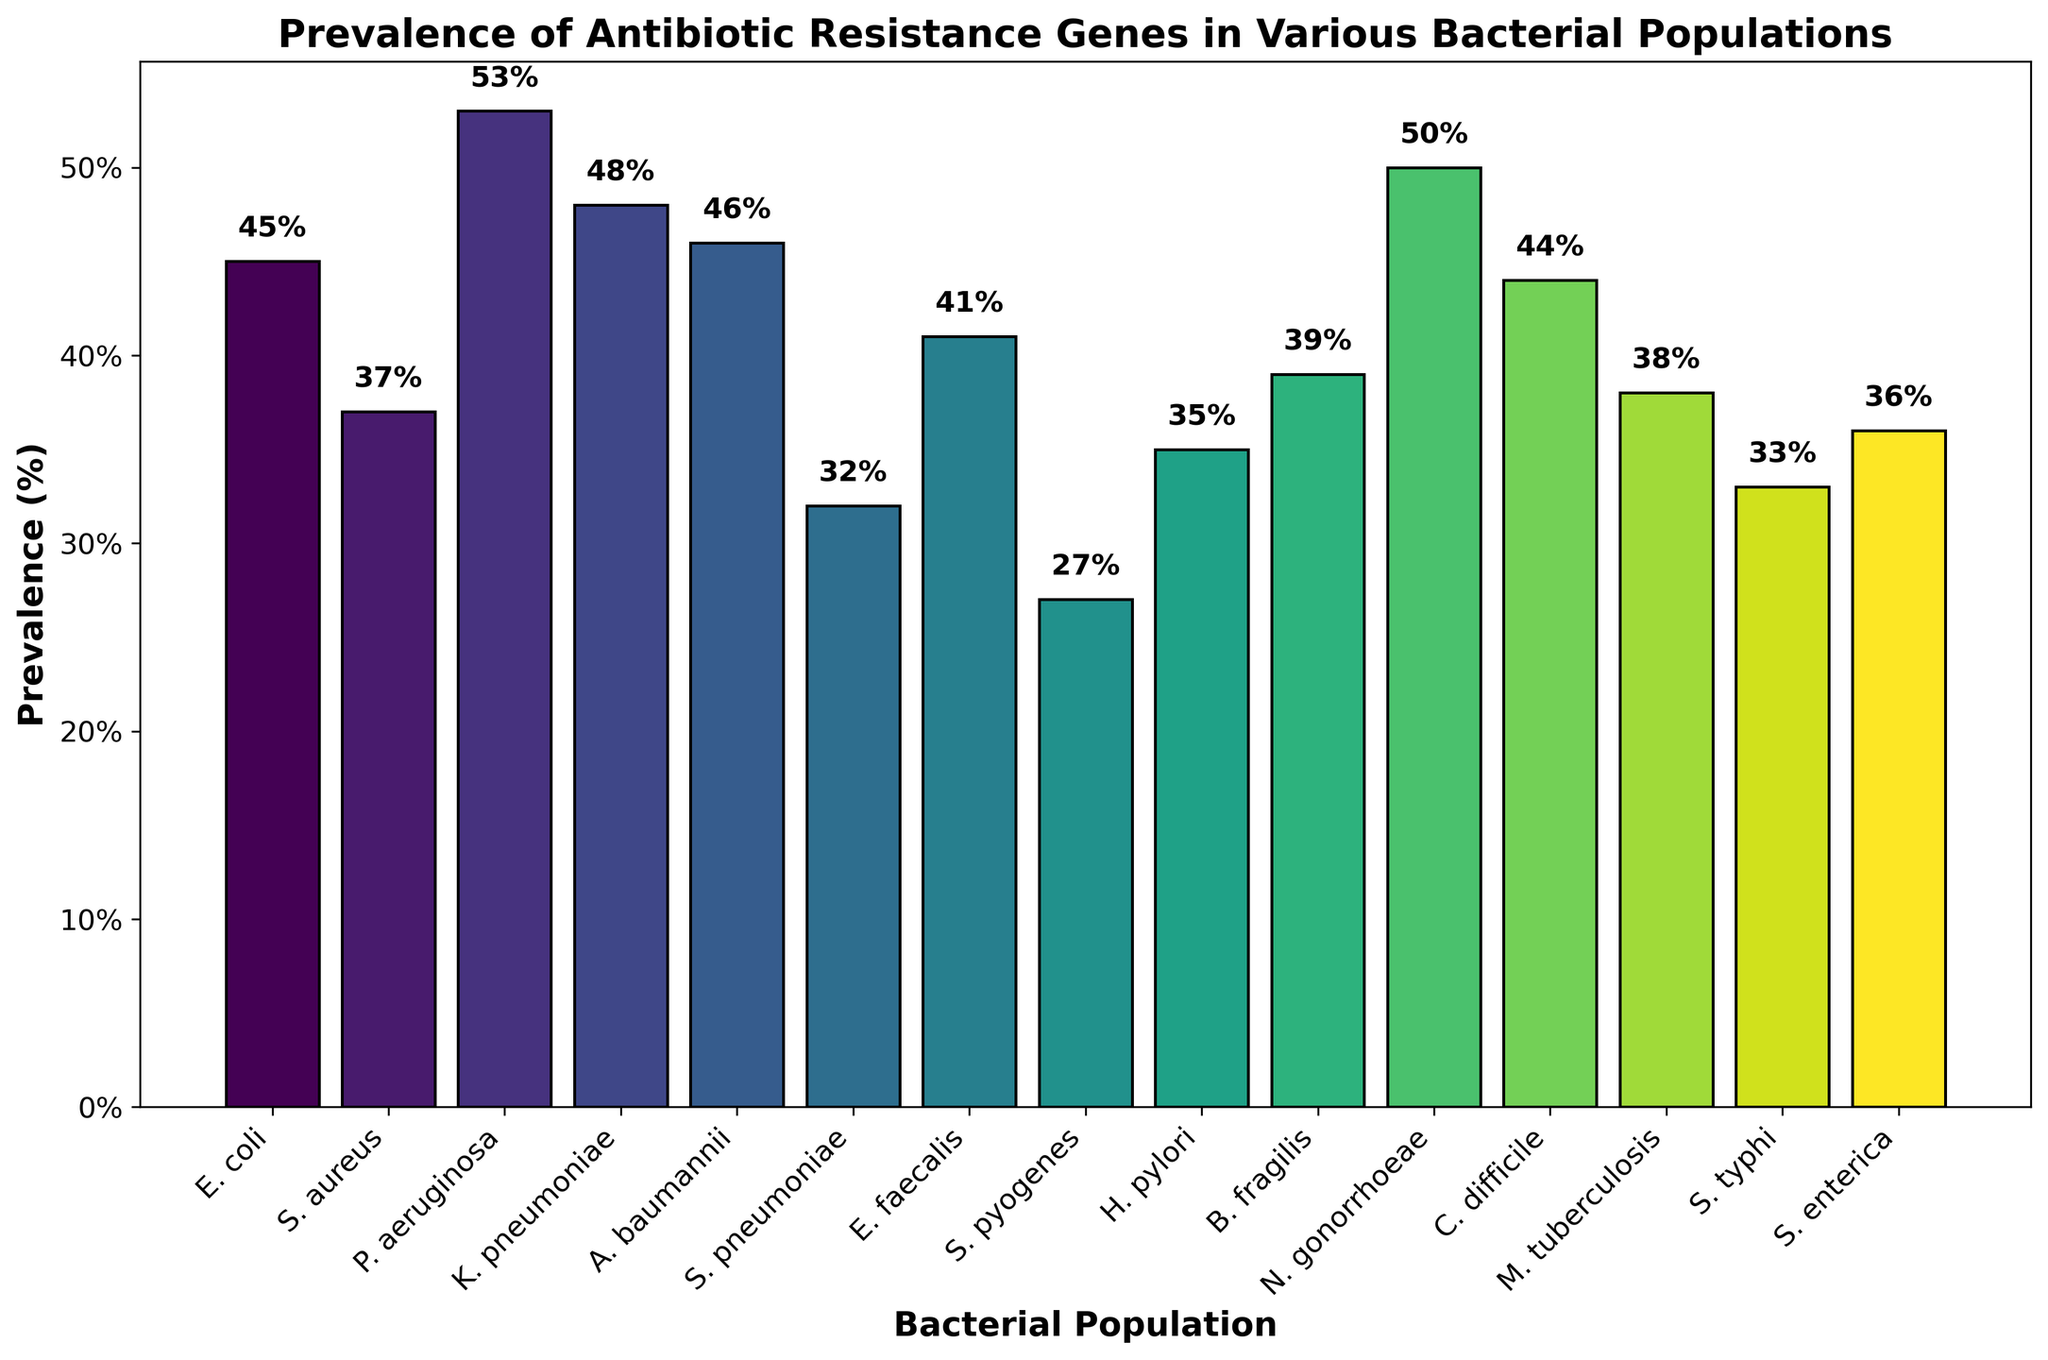Which bacterial population has the highest prevalence of antibiotic resistance genes? Identify the tallest bar in the figure. The tallest bar corresponds to P. aeruginosa with a value of 53%.
Answer: P. aeruginosa Which bacterial population has the lowest prevalence of antibiotic resistance genes? Look for the shortest bar in the figure. The shortest bar corresponds to S. pyogenes with a value of 27%.
Answer: S. pyogenes How much higher is the prevalence in N. gonorrhoeae compared to H. pylori? Find the bars for N. gonorrhoeae and H. pylori. N. gonorrhoeae is at 50% and H. pylori is at 35%. Calculate the difference: 50% - 35% = 15%.
Answer: 15% What is the average prevalence of antibiotic resistance genes across all bacterial populations? Sum the prevalence values: 45 + 37 + 53 + 48 + 46 + 32 + 41 + 27 + 35 + 39 + 50 + 44 + 38 + 33 + 36 = 604. Divide by the number of populations (15) to get the average: 604 / 15 ≈ 40.27%.
Answer: 40.27% Which bacterial populations have a prevalence of antibiotic resistance genes greater than 45%? Identify the bars with values over 45%. These are E. coli (45%), P. aeruginosa (53%), K. pneumoniae (48%), A. baumannii (46%), N. gonorrhoeae (50%).
Answer: P. aeruginosa, K. pneumoniae, N. gonorrhoeae Is the prevalence of antibiotic resistance genes in S. aureus higher or lower than in E. faecalis? Compare the heights of the bars for S. aureus (37%) and E. faecalis (41%). E. faecalis has a higher prevalence.
Answer: Lower What is the combined prevalence of antibiotic resistance genes in S. pneumoniae and S. typhi? Add the values for S. pneumoniae (32%) and S. typhi (33%): 32% + 33% = 65%.
Answer: 65% Which bacterial population(s) have a prevalence close to the median prevalence reported in the study? Order the populations by prevalence and find the median value. Median of 15 values is the 8th value when ordered: 45, 37, 53, 48, 46, 32, 41, 27, 35, 39, 50, 44, 38, 33, 36. Median is 39%, associated with B. fragilis.
Answer: B. fragilis How does the prevalence of C. difficile compare to the overall average prevalence? Overall average prevalence = 40.27%. Prevalence in C. difficile is 44%. Compare the two values: 44% is higher than the average of 40.27%.
Answer: Higher What is the total prevalence percentage for all Gram-negative bacteria listed? Identify and sum the prevalence for Gram-negative bacteria: E. coli (45%), P. aeruginosa (53%), K. pneumoniae (48%), A. baumannii (46%), H. pylori (35%), E. faecalis (41%), B. fragilis (39%), N. gonorrhoeae (50%), S. typhi (33%), S. enterica (36%). Total = 426%.
Answer: 426% 